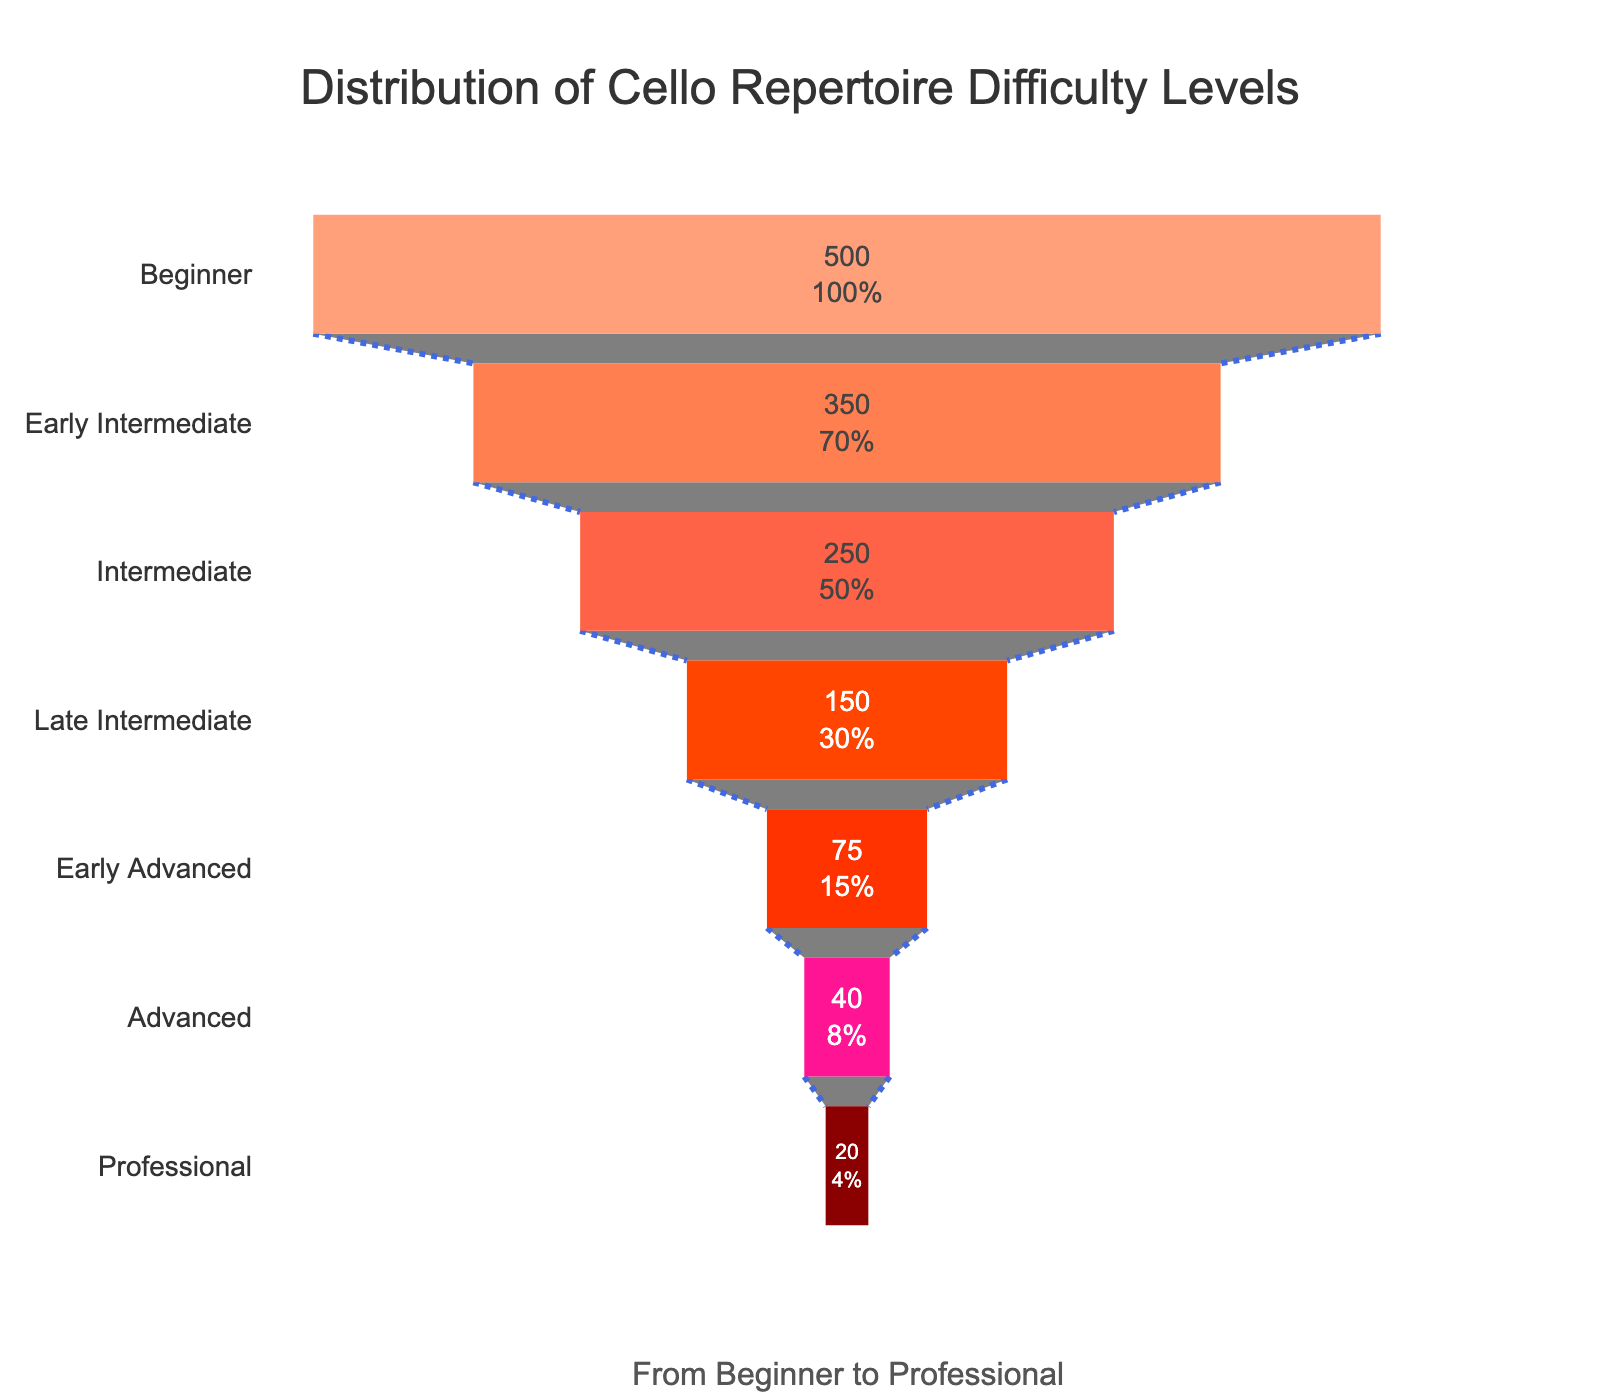What does the title of the chart indicate? The title of the chart, "Distribution of Cello Repertoire Difficulty Levels," indicates that the chart shows how many cello pieces are available at each difficulty level, from beginner to professional.
Answer: Distribution of Cello Repertoire Difficulty Levels How many difficulty levels are displayed in the chart? There are visually discernible sections for each difficulty level, listing totals for each, from Beginner to Professional, making it straightforward to count.
Answer: Seven Which difficulty level has the highest number of pieces? By looking at the funnel chart and observing the largest section, which contains the highest count, we can see that the Beginner level is the widest.
Answer: Beginner What's the total number of pieces for the Intermediate and Advanced levels combined? First, locate the sections for Intermediate (250 pieces) and Advanced (40 pieces) and add them together: 250 + 40 = 290.
Answer: 290 What percentage of pieces are classified as Professional, according to the chart? The Professional section has 20 pieces. The total number of pieces in the chart is 500 + 350 + 250 + 150 + 75 + 40 + 20 = 1385. The percentage is (20 / 1385) * 100 ≈ 1.44%.
Answer: 1.44% Which difficulty level has fewer pieces than Late Intermediate but more pieces than Professional? By comparing the number of pieces, we see that Early Advanced, with 75 pieces, fits this criterion (Late Intermediate has 150, Professional has 20).
Answer: Early Advanced How does the number of Beginner pieces compare to the number of Professional pieces? The Beginner level has significantly more pieces (500) compared to the Professional level (20). It's evident visually that the Beginner section is much larger than the Professional section.
Answer: Far more What is the ratio of Early Intermediate pieces to Late Intermediate pieces? Early Intermediate has 350 pieces, and Late Intermediate has 150 pieces. The ratio is 350:150, which simplifies to 7:3.
Answer: 7:3 If a piece was chosen at random, what is the probability it is classified under Early Intermediate? With 350 Early Intermediate pieces out of a total of 1385, the probability is 350 / 1385 ≈ 0.253, or roughly 25.3%.
Answer: 25.3% How does the count of Early Advanced pieces compare to the sum of Beginner and Professional pieces? Early Advanced has 75 pieces. The sum of Beginner and Professional pieces is 500 + 20 = 520. Comparatively, Early Advanced has significantly fewer pieces.
Answer: Significantly fewer 